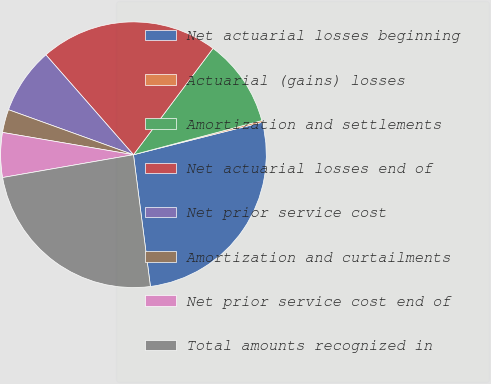Convert chart to OTSL. <chart><loc_0><loc_0><loc_500><loc_500><pie_chart><fcel>Net actuarial losses beginning<fcel>Actuarial (gains) losses<fcel>Amortization and settlements<fcel>Net actuarial losses end of<fcel>Net prior service cost<fcel>Amortization and curtailments<fcel>Net prior service cost end of<fcel>Total amounts recognized in<nl><fcel>26.89%<fcel>0.21%<fcel>10.64%<fcel>21.68%<fcel>8.04%<fcel>2.82%<fcel>5.43%<fcel>24.29%<nl></chart> 